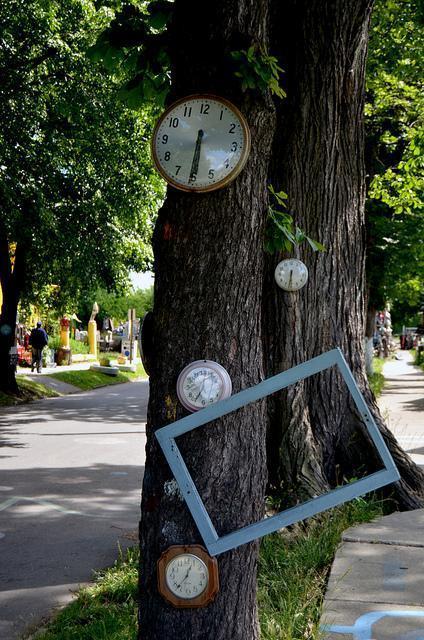How many clocks are on the tree?
Give a very brief answer. 4. 